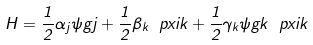Convert formula to latex. <formula><loc_0><loc_0><loc_500><loc_500>H = \frac { 1 } { 2 } \alpha _ { j } \psi g { j } + \frac { 1 } { 2 } \beta _ { k } \ p x i { k } + \frac { 1 } { 2 } \gamma _ { k } \psi g { k } \ p x i { k }</formula> 